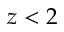Convert formula to latex. <formula><loc_0><loc_0><loc_500><loc_500>z < 2</formula> 